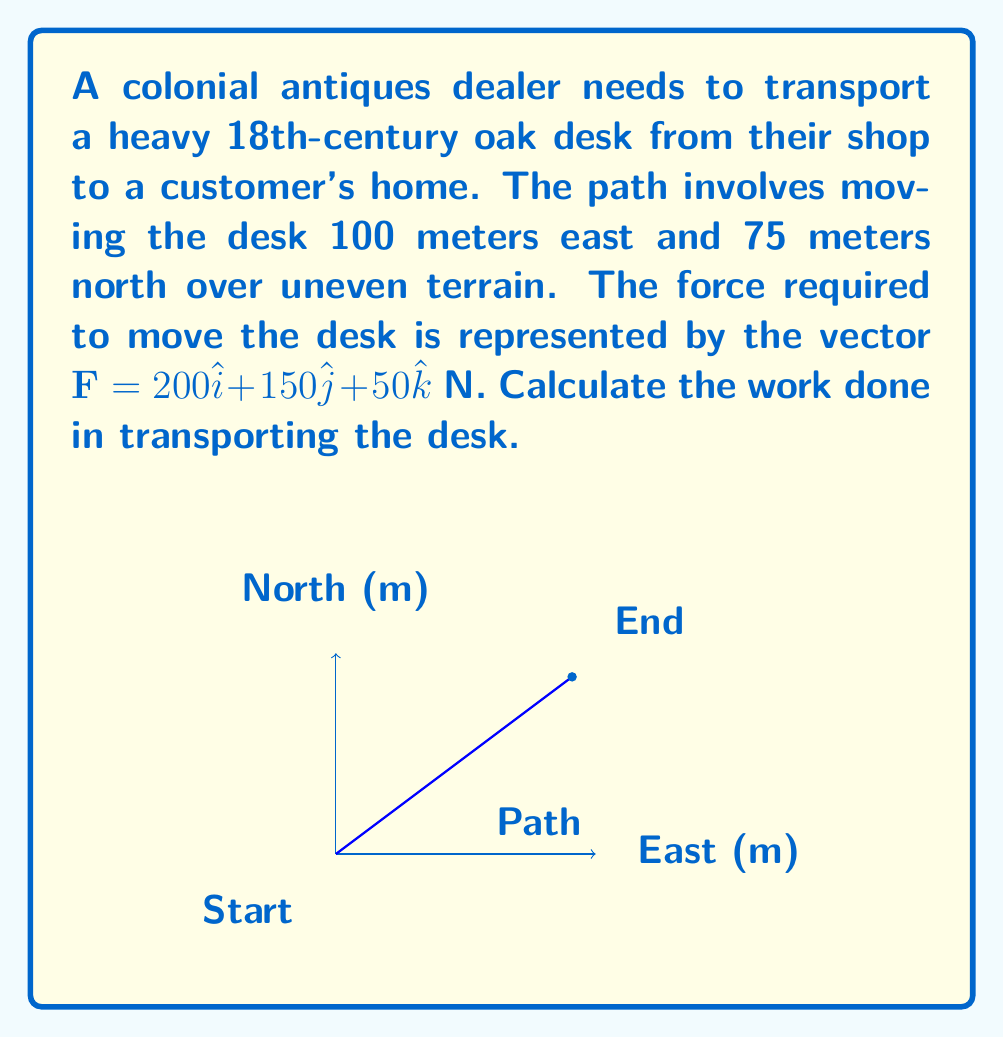Help me with this question. To solve this problem, we'll follow these steps:

1) Recall that work is defined as the dot product of force and displacement vectors:

   $W = \mathbf{F} \cdot \mathbf{d}$

2) We're given the force vector:
   
   $\mathbf{F} = 200\hat{i} + 150\hat{j} + 50\hat{k}$ N

3) We need to determine the displacement vector. From the information given:
   
   $\mathbf{d} = 100\hat{i} + 75\hat{j} + 0\hat{k}$ m

4) Now we can calculate the dot product:

   $W = (200\hat{i} + 150\hat{j} + 50\hat{k}) \cdot (100\hat{i} + 75\hat{j} + 0\hat{k})$

5) Multiply corresponding components and sum:

   $W = (200 \cdot 100) + (150 \cdot 75) + (50 \cdot 0)$

6) Calculate:

   $W = 20,000 + 11,250 + 0 = 31,250$ J

Therefore, the work done in transporting the antique desk is 31,250 Joules.
Answer: $31,250$ J 